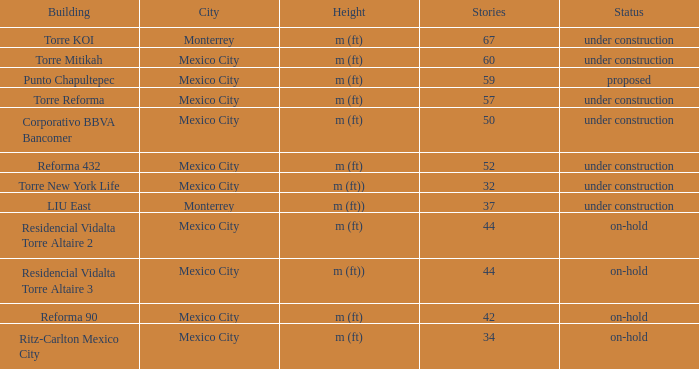How tall is the 52 story building? M (ft). 